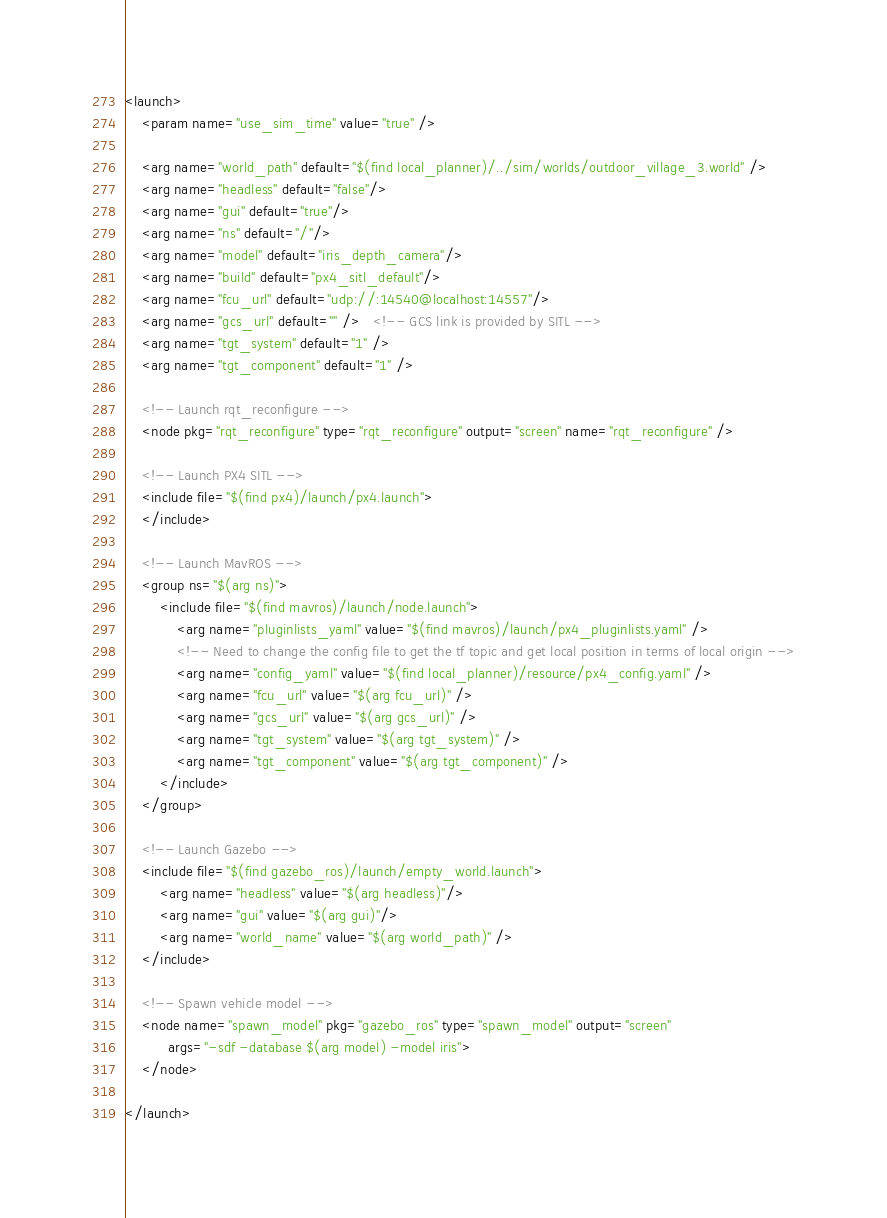<code> <loc_0><loc_0><loc_500><loc_500><_XML_><launch>
    <param name="use_sim_time" value="true" />

    <arg name="world_path" default="$(find local_planner)/../sim/worlds/outdoor_village_3.world" />
    <arg name="headless" default="false"/>
    <arg name="gui" default="true"/>
    <arg name="ns" default="/"/>
    <arg name="model" default="iris_depth_camera"/>
    <arg name="build" default="px4_sitl_default"/>
    <arg name="fcu_url" default="udp://:14540@localhost:14557"/>
    <arg name="gcs_url" default="" />   <!-- GCS link is provided by SITL -->
    <arg name="tgt_system" default="1" />
    <arg name="tgt_component" default="1" />

    <!-- Launch rqt_reconfigure -->
    <node pkg="rqt_reconfigure" type="rqt_reconfigure" output="screen" name="rqt_reconfigure" />

    <!-- Launch PX4 SITL -->
    <include file="$(find px4)/launch/px4.launch">
    </include>

    <!-- Launch MavROS -->
    <group ns="$(arg ns)">
        <include file="$(find mavros)/launch/node.launch">
            <arg name="pluginlists_yaml" value="$(find mavros)/launch/px4_pluginlists.yaml" />
            <!-- Need to change the config file to get the tf topic and get local position in terms of local origin -->
            <arg name="config_yaml" value="$(find local_planner)/resource/px4_config.yaml" />
            <arg name="fcu_url" value="$(arg fcu_url)" />
            <arg name="gcs_url" value="$(arg gcs_url)" />
            <arg name="tgt_system" value="$(arg tgt_system)" />
            <arg name="tgt_component" value="$(arg tgt_component)" />
        </include>
    </group>

    <!-- Launch Gazebo -->
    <include file="$(find gazebo_ros)/launch/empty_world.launch">
        <arg name="headless" value="$(arg headless)"/>
        <arg name="gui" value="$(arg gui)"/>
        <arg name="world_name" value="$(arg world_path)" />
    </include>

    <!-- Spawn vehicle model -->
    <node name="spawn_model" pkg="gazebo_ros" type="spawn_model" output="screen"
          args="-sdf -database $(arg model) -model iris">
    </node>

</launch>
</code> 